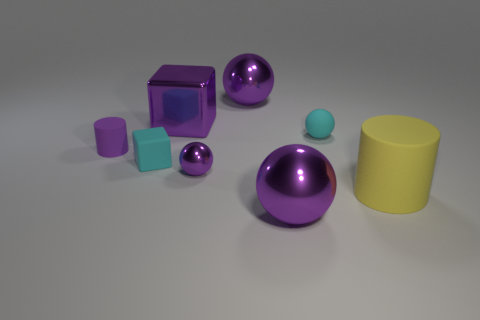Subtract all tiny purple balls. How many balls are left? 3 Subtract all cyan spheres. How many spheres are left? 3 Subtract all cylinders. How many objects are left? 6 Subtract 2 cylinders. How many cylinders are left? 0 Subtract all red balls. How many blue cubes are left? 0 Add 8 tiny purple cylinders. How many tiny purple cylinders are left? 9 Add 1 cyan shiny cylinders. How many cyan shiny cylinders exist? 1 Add 2 small purple spheres. How many objects exist? 10 Subtract 0 green blocks. How many objects are left? 8 Subtract all blue cubes. Subtract all brown cylinders. How many cubes are left? 2 